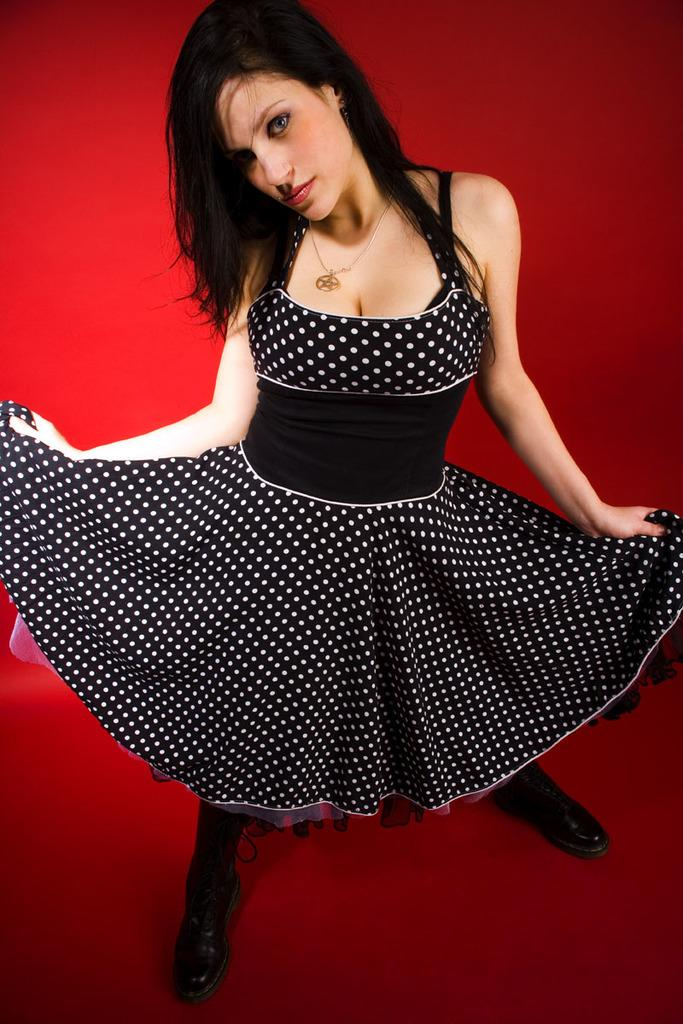Who is the main subject in the image? There is a woman in the image. What is the woman wearing? The woman is wearing a black dress and black shoes. What is the woman doing in the image? The woman is posing for a photo. What color is the background of the image? The background of the image is red in color. Is the woman standing in quicksand in the image? No, there is no quicksand present in the image. What type of heat source can be seen in the image? There is no heat source visible in the image. 